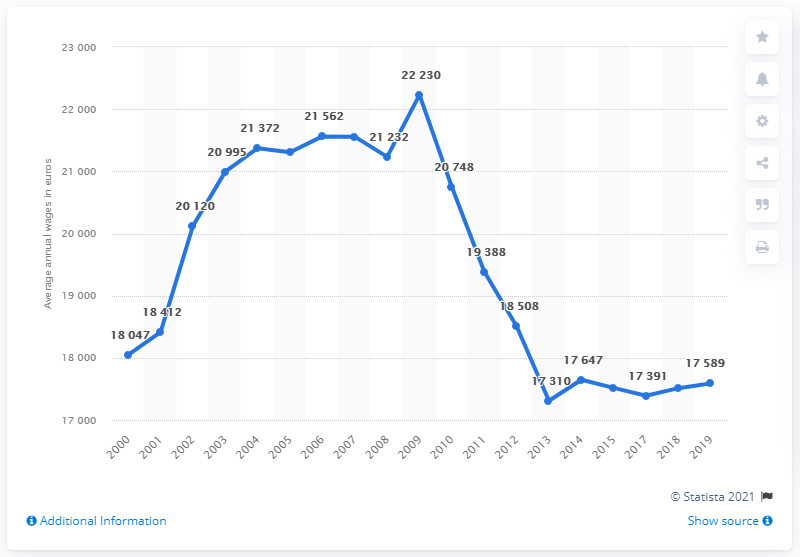Indicate a few pertinent items in this graphic. In 2018, the average annual wage in Greece was 17,589 euros. The average annual wages in Greece in 2012 were 18,508. The average annual wages in Greece from 2017 to 2019 were approximately 17,490 euros. 